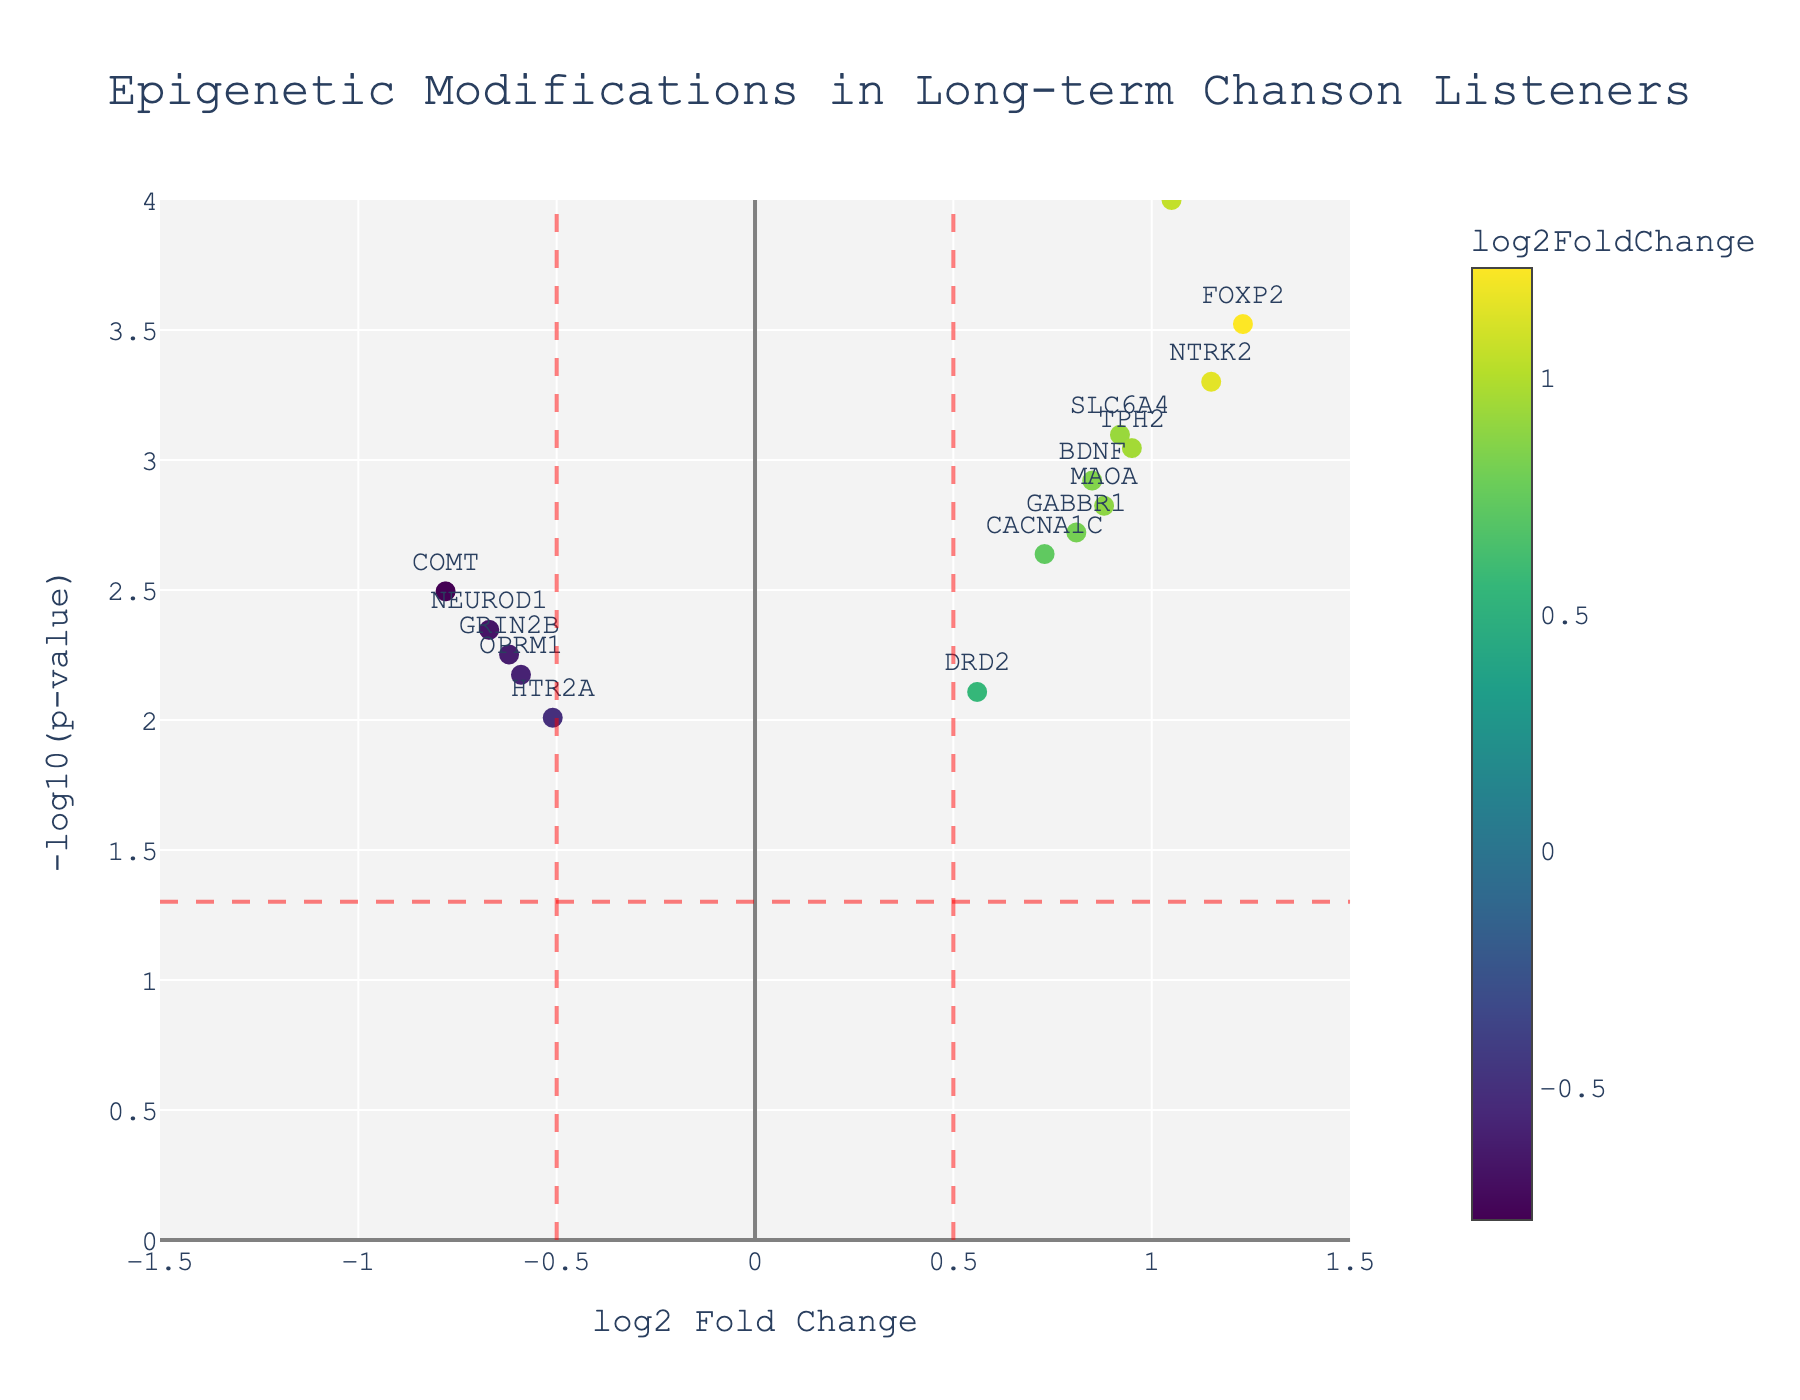What does the x-axis represent? The x-axis represents log2 Fold Change, which indicates the magnitude of change in gene expression between long-term chanson listeners and casual listeners. Positive values mean higher expression in long-term listeners, while negative values mean lower expression.
Answer: log2 Fold Change What does the y-axis represent? The y-axis represents -log10(p-value), which essentially tells us the significance of the change. Higher values indicate more statistically significant differences.
Answer: -log10(p-value) Which gene shows the largest log2 Fold Change? To find the gene with the largest log2 Fold Change, we look for the farthest data point along the x-axis in either direction. FOXP2 has the highest value at 1.23.
Answer: FOXP2 Which gene is the most statistically significant? The most statistically significant gene will have the highest -log10(p-value) on the y-axis. OXTR has the highest y-value, indicating the lowest p-value at 0.0001.
Answer: OXTR How many genes are upregulated (log2 Fold Change > 0.5 and statistically significant (p-value < 0.05)? Count the data points that are right of the 0.5 vertical red line and above the horizontal red line at -log10(0.05). The genes BDNF, FOXP2, SLC6A4, OXTR, and TPH2 meet these criteria.
Answer: 5 Which gene has the lowest p-value? We identify the gene with the highest point on the y-axis since higher values of -log10(p-value) correspond to lower p-values. OXTR has the lowest p-value.
Answer: OXTR Is there a gene with a positive log2 Fold Change and not statistically significant? Check for points with log2 Fold Change > 0.5 but below the horizontal red line at -log10(0.05). DRD2 has a positive log2 Fold Change but is below the significance threshold.
Answer: DRD2 Which gene has the most negative log2 Fold Change but is statistically significant? Locate the most leftward point that is above the horizontal red line. COMT has the lowest log2 Fold Change at -0.78 but is significant with a p-value of 0.0032.
Answer: COMT What is the range of the y-axis values? Check the y-axis range from the bottom to the top, which is from 0 to 4 as indicated in the figure's axis settings.
Answer: 0 to 4 